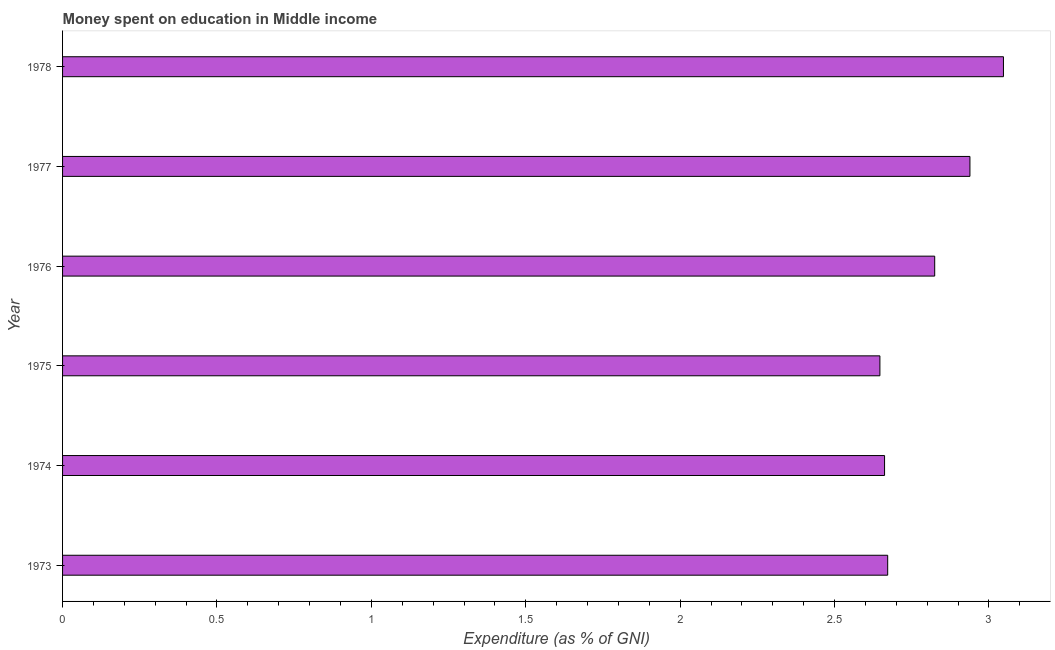Does the graph contain grids?
Your answer should be compact. No. What is the title of the graph?
Provide a short and direct response. Money spent on education in Middle income. What is the label or title of the X-axis?
Keep it short and to the point. Expenditure (as % of GNI). What is the label or title of the Y-axis?
Make the answer very short. Year. What is the expenditure on education in 1975?
Give a very brief answer. 2.65. Across all years, what is the maximum expenditure on education?
Your response must be concise. 3.05. Across all years, what is the minimum expenditure on education?
Give a very brief answer. 2.65. In which year was the expenditure on education maximum?
Give a very brief answer. 1978. In which year was the expenditure on education minimum?
Provide a succinct answer. 1975. What is the sum of the expenditure on education?
Provide a succinct answer. 16.79. What is the difference between the expenditure on education in 1975 and 1976?
Your response must be concise. -0.18. What is the average expenditure on education per year?
Make the answer very short. 2.8. What is the median expenditure on education?
Your answer should be very brief. 2.75. Do a majority of the years between 1975 and 1974 (inclusive) have expenditure on education greater than 0.2 %?
Provide a short and direct response. No. What is the ratio of the expenditure on education in 1976 to that in 1978?
Make the answer very short. 0.93. What is the difference between the highest and the second highest expenditure on education?
Provide a short and direct response. 0.11. Is the sum of the expenditure on education in 1974 and 1978 greater than the maximum expenditure on education across all years?
Provide a succinct answer. Yes. Are all the bars in the graph horizontal?
Give a very brief answer. Yes. What is the Expenditure (as % of GNI) in 1973?
Give a very brief answer. 2.67. What is the Expenditure (as % of GNI) of 1974?
Offer a very short reply. 2.66. What is the Expenditure (as % of GNI) of 1975?
Keep it short and to the point. 2.65. What is the Expenditure (as % of GNI) of 1976?
Your answer should be compact. 2.82. What is the Expenditure (as % of GNI) of 1977?
Make the answer very short. 2.94. What is the Expenditure (as % of GNI) of 1978?
Provide a short and direct response. 3.05. What is the difference between the Expenditure (as % of GNI) in 1973 and 1974?
Your answer should be very brief. 0.01. What is the difference between the Expenditure (as % of GNI) in 1973 and 1975?
Make the answer very short. 0.03. What is the difference between the Expenditure (as % of GNI) in 1973 and 1976?
Your response must be concise. -0.15. What is the difference between the Expenditure (as % of GNI) in 1973 and 1977?
Make the answer very short. -0.27. What is the difference between the Expenditure (as % of GNI) in 1973 and 1978?
Provide a short and direct response. -0.37. What is the difference between the Expenditure (as % of GNI) in 1974 and 1975?
Make the answer very short. 0.02. What is the difference between the Expenditure (as % of GNI) in 1974 and 1976?
Provide a succinct answer. -0.16. What is the difference between the Expenditure (as % of GNI) in 1974 and 1977?
Your response must be concise. -0.28. What is the difference between the Expenditure (as % of GNI) in 1974 and 1978?
Offer a terse response. -0.38. What is the difference between the Expenditure (as % of GNI) in 1975 and 1976?
Provide a succinct answer. -0.18. What is the difference between the Expenditure (as % of GNI) in 1975 and 1977?
Keep it short and to the point. -0.29. What is the difference between the Expenditure (as % of GNI) in 1975 and 1978?
Make the answer very short. -0.4. What is the difference between the Expenditure (as % of GNI) in 1976 and 1977?
Provide a short and direct response. -0.11. What is the difference between the Expenditure (as % of GNI) in 1976 and 1978?
Your answer should be very brief. -0.22. What is the difference between the Expenditure (as % of GNI) in 1977 and 1978?
Ensure brevity in your answer.  -0.11. What is the ratio of the Expenditure (as % of GNI) in 1973 to that in 1976?
Make the answer very short. 0.95. What is the ratio of the Expenditure (as % of GNI) in 1973 to that in 1977?
Offer a very short reply. 0.91. What is the ratio of the Expenditure (as % of GNI) in 1973 to that in 1978?
Keep it short and to the point. 0.88. What is the ratio of the Expenditure (as % of GNI) in 1974 to that in 1976?
Ensure brevity in your answer.  0.94. What is the ratio of the Expenditure (as % of GNI) in 1974 to that in 1977?
Your answer should be very brief. 0.91. What is the ratio of the Expenditure (as % of GNI) in 1974 to that in 1978?
Provide a succinct answer. 0.87. What is the ratio of the Expenditure (as % of GNI) in 1975 to that in 1976?
Provide a short and direct response. 0.94. What is the ratio of the Expenditure (as % of GNI) in 1975 to that in 1977?
Give a very brief answer. 0.9. What is the ratio of the Expenditure (as % of GNI) in 1975 to that in 1978?
Give a very brief answer. 0.87. What is the ratio of the Expenditure (as % of GNI) in 1976 to that in 1977?
Provide a short and direct response. 0.96. What is the ratio of the Expenditure (as % of GNI) in 1976 to that in 1978?
Provide a succinct answer. 0.93. 